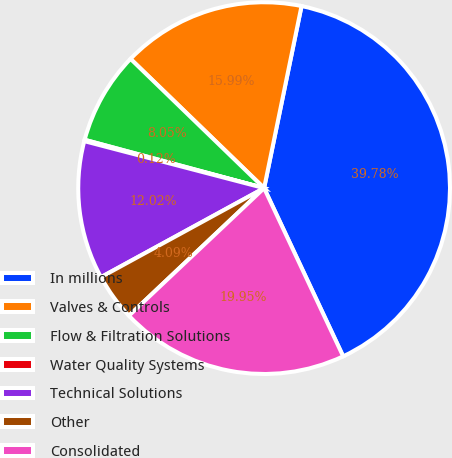<chart> <loc_0><loc_0><loc_500><loc_500><pie_chart><fcel>In millions<fcel>Valves & Controls<fcel>Flow & Filtration Solutions<fcel>Water Quality Systems<fcel>Technical Solutions<fcel>Other<fcel>Consolidated<nl><fcel>39.78%<fcel>15.99%<fcel>8.05%<fcel>0.12%<fcel>12.02%<fcel>4.09%<fcel>19.95%<nl></chart> 